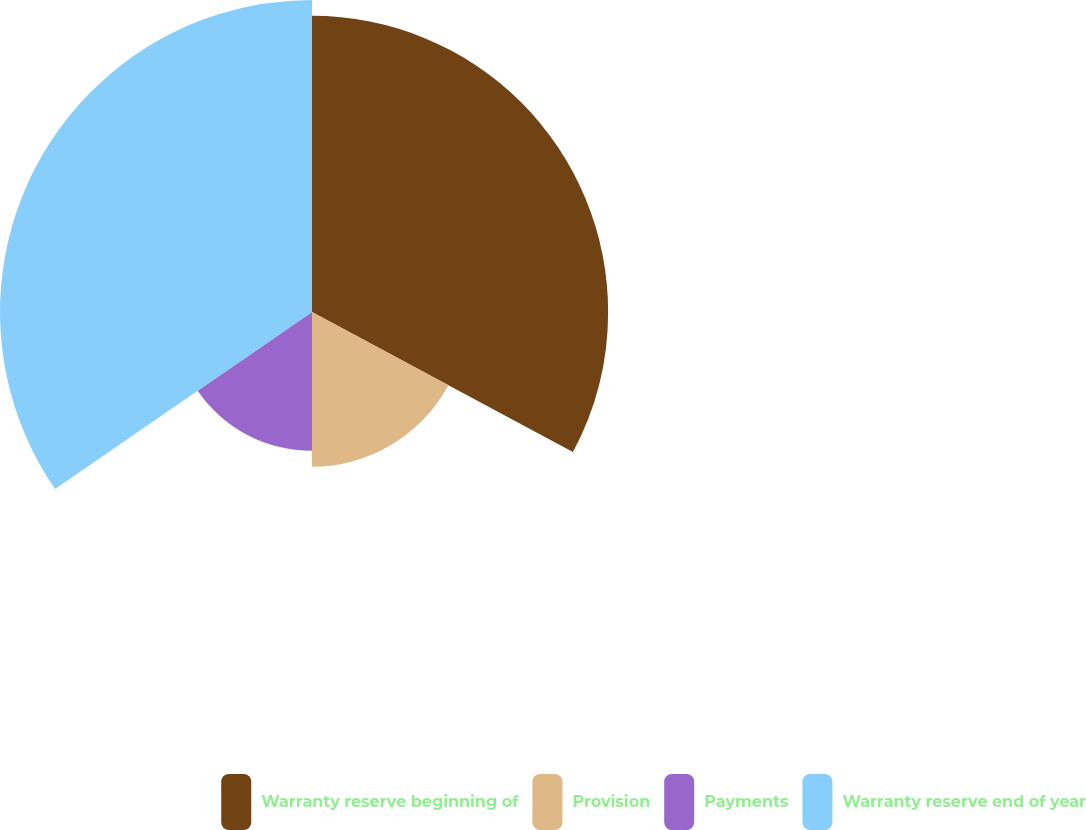Convert chart to OTSL. <chart><loc_0><loc_0><loc_500><loc_500><pie_chart><fcel>Warranty reserve beginning of<fcel>Provision<fcel>Payments<fcel>Warranty reserve end of year<nl><fcel>32.84%<fcel>17.16%<fcel>15.4%<fcel>34.6%<nl></chart> 